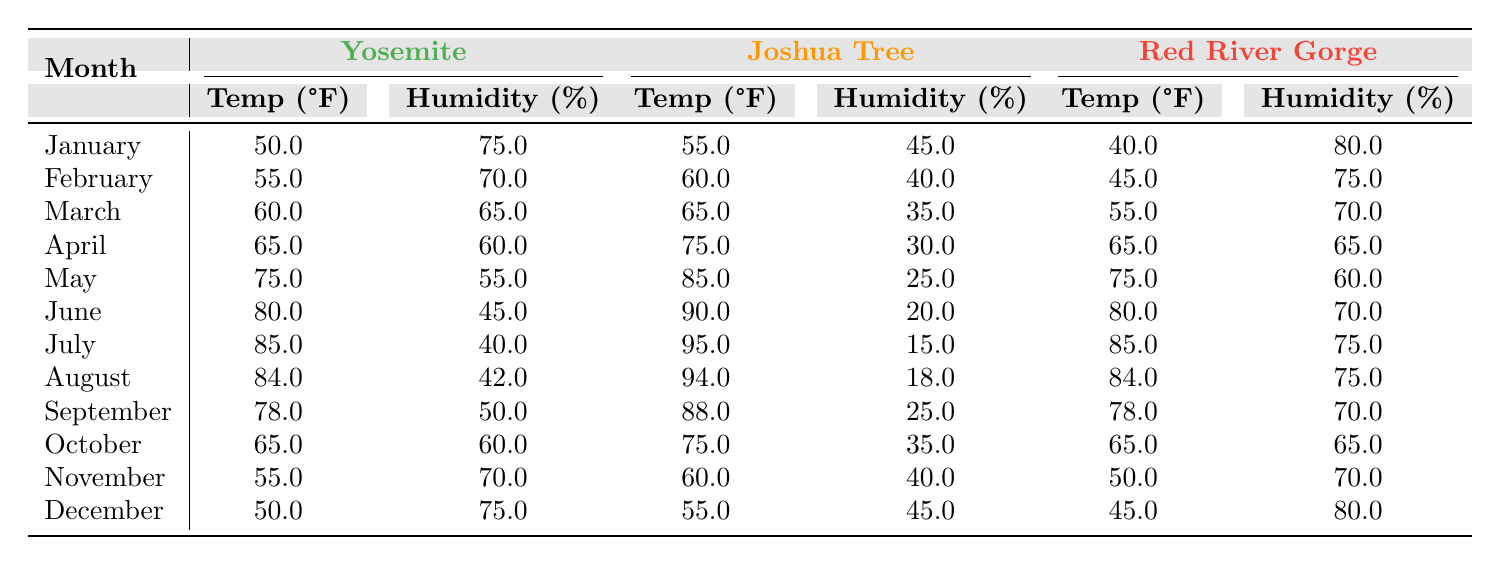What is the average temperature in Yosemite for the month of June? From the table, the average temperature in Yosemite for June is listed as 80°F. Therefore, there's no need for further calculation.
Answer: 80°F Which climbing area has the highest average humidity in January? In January, the humidity levels are: Yosemite at 75%, Joshua Tree at 45%, and Red River Gorge at 80%. Comparing these, Red River Gorge has the highest humidity level in January.
Answer: Red River Gorge What is the difference in average temperature between July in Joshua Tree and September in Yosemite? The average temperature for Joshua Tree in July is 95°F and for Yosemite in September is 78°F. The difference is calculated by subtracting 78 from 95, which equals 17.
Answer: 17°F Is the average humidity in April higher in Red River Gorge than in Joshua Tree? The average humidity in April for Red River Gorge is 65%, while for Joshua Tree, it is 30%. Since 65% is greater than 30%, the statement is true.
Answer: Yes What is the average temperature for all three climbing areas in August? The average temperatures in August are: Yosemite 84°F, Joshua Tree 94°F, and Red River Gorge 84°F. To find the average, we add them (84 + 94 + 84 = 262) and divide by 3. Thus, the average temperature is 262 ÷ 3 = 87.33°F (or roughly 87°F).
Answer: 87°F Which month has the lowest average temperature in Red River Gorge? Looking at the data, the monthly temperatures in Red River Gorge show January as 40°F, February at 45°F, and higher for subsequent months. January is the lowest average temperature.
Answer: January What is the average humidity percentage in June for both Yosemite and Joshua Tree combined? The average humidity for June in Yosemite is 45%, and for Joshua Tree, it is 20%. To find the combined average, we add 45 + 20 = 65 and divide by 2, giving us 32.5%.
Answer: 32.5% Are temperatures in Yosemite higher than 80°F in July and August? In July, Yosemite's temperature is 85°F, and in August, it's 84°F. Both values are greater than 80°F, confirming that the temperatures in these months are indeed higher.
Answer: Yes 